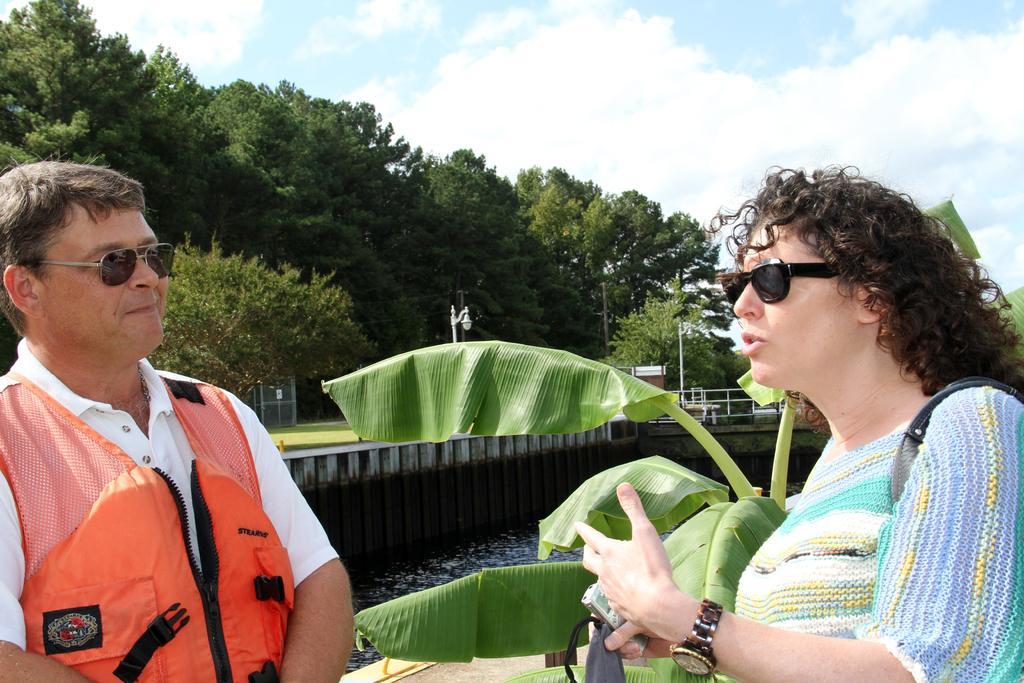Can you describe this image briefly? On the left side of the image there is a man with goggles and a life jacket. On the right side of the image there is a lady with goggles and there is a watch on her hand. Behind them there are leaves. And also there is water. There is a wall, bridge and railings. And also there are trees, fencing and poles. At the top of the image there is sky with clouds. 